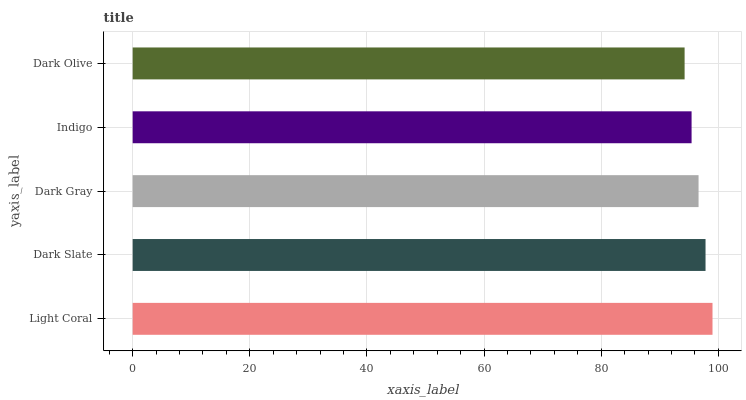Is Dark Olive the minimum?
Answer yes or no. Yes. Is Light Coral the maximum?
Answer yes or no. Yes. Is Dark Slate the minimum?
Answer yes or no. No. Is Dark Slate the maximum?
Answer yes or no. No. Is Light Coral greater than Dark Slate?
Answer yes or no. Yes. Is Dark Slate less than Light Coral?
Answer yes or no. Yes. Is Dark Slate greater than Light Coral?
Answer yes or no. No. Is Light Coral less than Dark Slate?
Answer yes or no. No. Is Dark Gray the high median?
Answer yes or no. Yes. Is Dark Gray the low median?
Answer yes or no. Yes. Is Dark Slate the high median?
Answer yes or no. No. Is Indigo the low median?
Answer yes or no. No. 